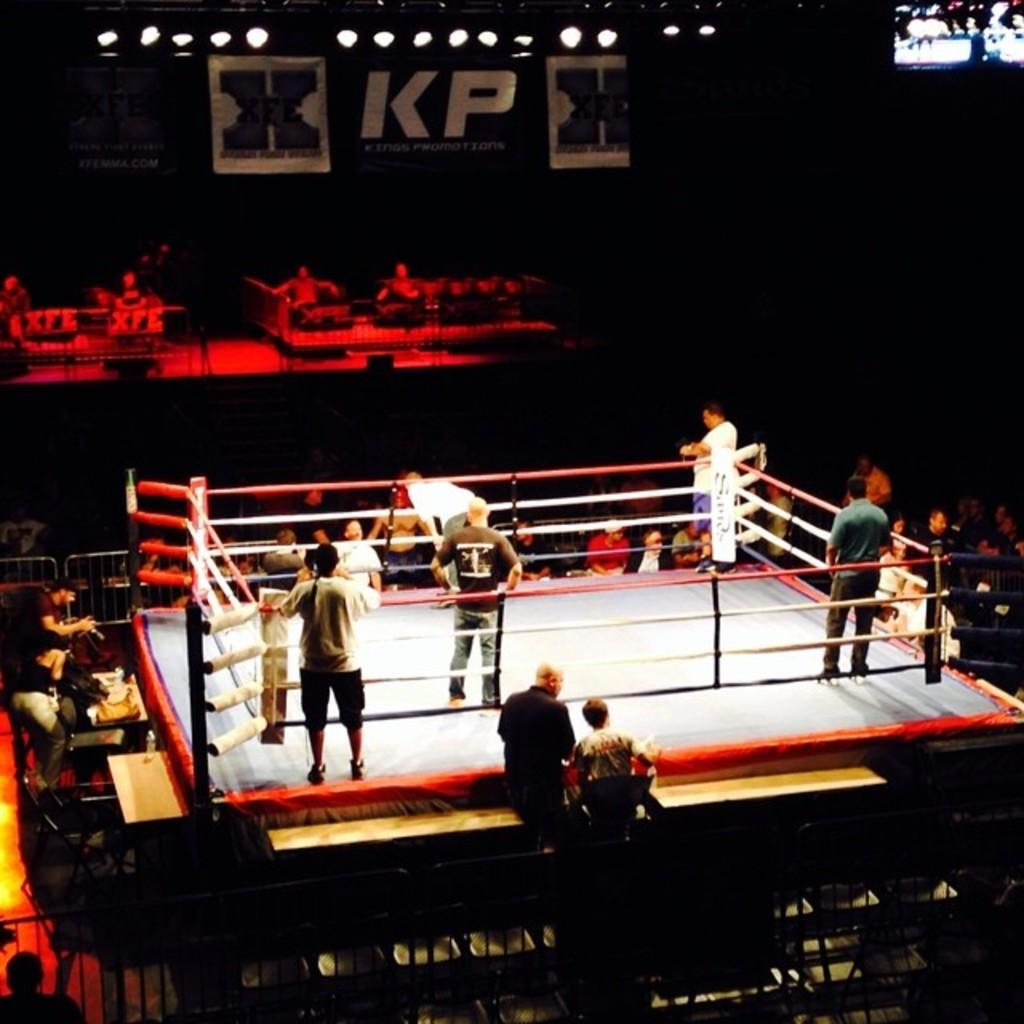What are the 2 letters between the x's?
Provide a succinct answer. Kp. What is the logo on the post on the top right?
Make the answer very short. Unanswerable. 